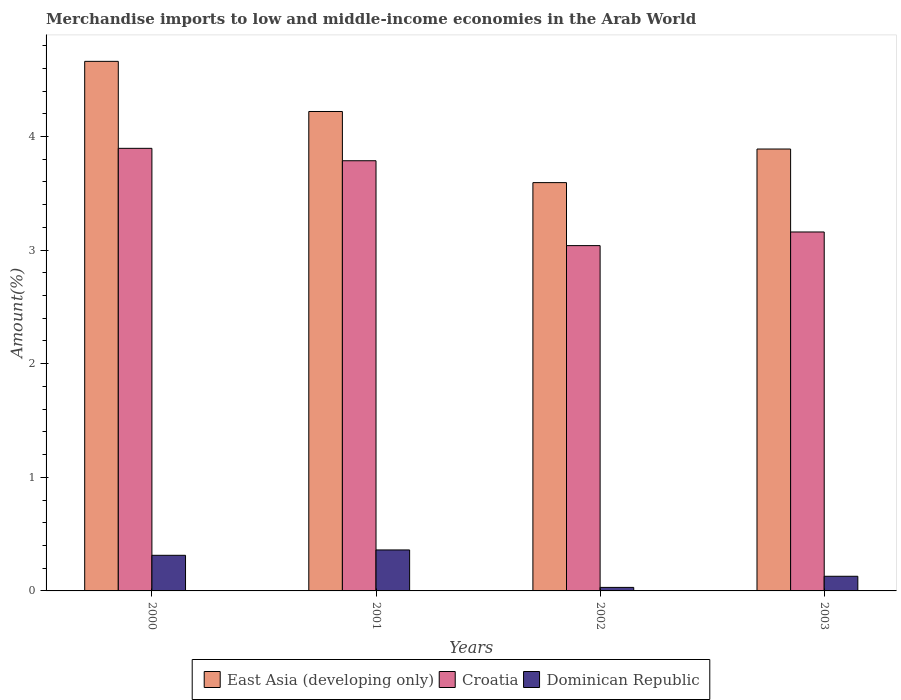How many bars are there on the 3rd tick from the left?
Your answer should be compact. 3. In how many cases, is the number of bars for a given year not equal to the number of legend labels?
Your response must be concise. 0. What is the percentage of amount earned from merchandise imports in Dominican Republic in 2002?
Offer a very short reply. 0.03. Across all years, what is the maximum percentage of amount earned from merchandise imports in Dominican Republic?
Keep it short and to the point. 0.36. Across all years, what is the minimum percentage of amount earned from merchandise imports in East Asia (developing only)?
Make the answer very short. 3.59. In which year was the percentage of amount earned from merchandise imports in Croatia minimum?
Keep it short and to the point. 2002. What is the total percentage of amount earned from merchandise imports in Dominican Republic in the graph?
Ensure brevity in your answer.  0.83. What is the difference between the percentage of amount earned from merchandise imports in Dominican Republic in 2001 and that in 2003?
Make the answer very short. 0.23. What is the difference between the percentage of amount earned from merchandise imports in East Asia (developing only) in 2000 and the percentage of amount earned from merchandise imports in Croatia in 2003?
Provide a short and direct response. 1.5. What is the average percentage of amount earned from merchandise imports in Dominican Republic per year?
Provide a short and direct response. 0.21. In the year 2002, what is the difference between the percentage of amount earned from merchandise imports in Croatia and percentage of amount earned from merchandise imports in Dominican Republic?
Keep it short and to the point. 3.01. What is the ratio of the percentage of amount earned from merchandise imports in Croatia in 2000 to that in 2001?
Your answer should be compact. 1.03. Is the difference between the percentage of amount earned from merchandise imports in Croatia in 2000 and 2002 greater than the difference between the percentage of amount earned from merchandise imports in Dominican Republic in 2000 and 2002?
Your response must be concise. Yes. What is the difference between the highest and the second highest percentage of amount earned from merchandise imports in East Asia (developing only)?
Your response must be concise. 0.44. What is the difference between the highest and the lowest percentage of amount earned from merchandise imports in Croatia?
Provide a succinct answer. 0.86. Is the sum of the percentage of amount earned from merchandise imports in East Asia (developing only) in 2002 and 2003 greater than the maximum percentage of amount earned from merchandise imports in Dominican Republic across all years?
Give a very brief answer. Yes. What does the 3rd bar from the left in 2002 represents?
Your answer should be compact. Dominican Republic. What does the 3rd bar from the right in 2001 represents?
Give a very brief answer. East Asia (developing only). Are all the bars in the graph horizontal?
Provide a short and direct response. No. How many years are there in the graph?
Your response must be concise. 4. Are the values on the major ticks of Y-axis written in scientific E-notation?
Give a very brief answer. No. Does the graph contain grids?
Offer a terse response. No. What is the title of the graph?
Ensure brevity in your answer.  Merchandise imports to low and middle-income economies in the Arab World. Does "Heavily indebted poor countries" appear as one of the legend labels in the graph?
Keep it short and to the point. No. What is the label or title of the Y-axis?
Your response must be concise. Amount(%). What is the Amount(%) in East Asia (developing only) in 2000?
Keep it short and to the point. 4.66. What is the Amount(%) in Croatia in 2000?
Keep it short and to the point. 3.9. What is the Amount(%) of Dominican Republic in 2000?
Your response must be concise. 0.31. What is the Amount(%) in East Asia (developing only) in 2001?
Provide a succinct answer. 4.22. What is the Amount(%) in Croatia in 2001?
Offer a terse response. 3.79. What is the Amount(%) of Dominican Republic in 2001?
Your answer should be compact. 0.36. What is the Amount(%) in East Asia (developing only) in 2002?
Your answer should be very brief. 3.59. What is the Amount(%) in Croatia in 2002?
Your answer should be very brief. 3.04. What is the Amount(%) of Dominican Republic in 2002?
Make the answer very short. 0.03. What is the Amount(%) of East Asia (developing only) in 2003?
Your answer should be very brief. 3.89. What is the Amount(%) in Croatia in 2003?
Keep it short and to the point. 3.16. What is the Amount(%) of Dominican Republic in 2003?
Your response must be concise. 0.13. Across all years, what is the maximum Amount(%) of East Asia (developing only)?
Make the answer very short. 4.66. Across all years, what is the maximum Amount(%) of Croatia?
Your response must be concise. 3.9. Across all years, what is the maximum Amount(%) in Dominican Republic?
Your response must be concise. 0.36. Across all years, what is the minimum Amount(%) in East Asia (developing only)?
Offer a terse response. 3.59. Across all years, what is the minimum Amount(%) in Croatia?
Your answer should be compact. 3.04. Across all years, what is the minimum Amount(%) in Dominican Republic?
Provide a succinct answer. 0.03. What is the total Amount(%) in East Asia (developing only) in the graph?
Provide a succinct answer. 16.36. What is the total Amount(%) of Croatia in the graph?
Provide a succinct answer. 13.88. What is the total Amount(%) in Dominican Republic in the graph?
Give a very brief answer. 0.83. What is the difference between the Amount(%) of East Asia (developing only) in 2000 and that in 2001?
Provide a succinct answer. 0.44. What is the difference between the Amount(%) in Croatia in 2000 and that in 2001?
Your answer should be very brief. 0.11. What is the difference between the Amount(%) in Dominican Republic in 2000 and that in 2001?
Offer a very short reply. -0.05. What is the difference between the Amount(%) of East Asia (developing only) in 2000 and that in 2002?
Provide a succinct answer. 1.07. What is the difference between the Amount(%) of Croatia in 2000 and that in 2002?
Keep it short and to the point. 0.86. What is the difference between the Amount(%) of Dominican Republic in 2000 and that in 2002?
Offer a terse response. 0.28. What is the difference between the Amount(%) of East Asia (developing only) in 2000 and that in 2003?
Offer a very short reply. 0.77. What is the difference between the Amount(%) in Croatia in 2000 and that in 2003?
Your answer should be very brief. 0.74. What is the difference between the Amount(%) of Dominican Republic in 2000 and that in 2003?
Your response must be concise. 0.18. What is the difference between the Amount(%) in East Asia (developing only) in 2001 and that in 2002?
Ensure brevity in your answer.  0.63. What is the difference between the Amount(%) of Croatia in 2001 and that in 2002?
Offer a terse response. 0.75. What is the difference between the Amount(%) of Dominican Republic in 2001 and that in 2002?
Your response must be concise. 0.33. What is the difference between the Amount(%) in East Asia (developing only) in 2001 and that in 2003?
Provide a succinct answer. 0.33. What is the difference between the Amount(%) of Croatia in 2001 and that in 2003?
Give a very brief answer. 0.63. What is the difference between the Amount(%) of Dominican Republic in 2001 and that in 2003?
Offer a terse response. 0.23. What is the difference between the Amount(%) of East Asia (developing only) in 2002 and that in 2003?
Give a very brief answer. -0.3. What is the difference between the Amount(%) of Croatia in 2002 and that in 2003?
Provide a succinct answer. -0.12. What is the difference between the Amount(%) of Dominican Republic in 2002 and that in 2003?
Make the answer very short. -0.1. What is the difference between the Amount(%) of East Asia (developing only) in 2000 and the Amount(%) of Croatia in 2001?
Keep it short and to the point. 0.87. What is the difference between the Amount(%) of East Asia (developing only) in 2000 and the Amount(%) of Dominican Republic in 2001?
Offer a terse response. 4.3. What is the difference between the Amount(%) of Croatia in 2000 and the Amount(%) of Dominican Republic in 2001?
Ensure brevity in your answer.  3.53. What is the difference between the Amount(%) of East Asia (developing only) in 2000 and the Amount(%) of Croatia in 2002?
Give a very brief answer. 1.62. What is the difference between the Amount(%) in East Asia (developing only) in 2000 and the Amount(%) in Dominican Republic in 2002?
Your response must be concise. 4.63. What is the difference between the Amount(%) in Croatia in 2000 and the Amount(%) in Dominican Republic in 2002?
Offer a very short reply. 3.86. What is the difference between the Amount(%) in East Asia (developing only) in 2000 and the Amount(%) in Croatia in 2003?
Provide a short and direct response. 1.5. What is the difference between the Amount(%) of East Asia (developing only) in 2000 and the Amount(%) of Dominican Republic in 2003?
Offer a very short reply. 4.53. What is the difference between the Amount(%) in Croatia in 2000 and the Amount(%) in Dominican Republic in 2003?
Provide a short and direct response. 3.77. What is the difference between the Amount(%) in East Asia (developing only) in 2001 and the Amount(%) in Croatia in 2002?
Offer a very short reply. 1.18. What is the difference between the Amount(%) in East Asia (developing only) in 2001 and the Amount(%) in Dominican Republic in 2002?
Provide a short and direct response. 4.19. What is the difference between the Amount(%) of Croatia in 2001 and the Amount(%) of Dominican Republic in 2002?
Your answer should be very brief. 3.76. What is the difference between the Amount(%) in East Asia (developing only) in 2001 and the Amount(%) in Croatia in 2003?
Keep it short and to the point. 1.06. What is the difference between the Amount(%) of East Asia (developing only) in 2001 and the Amount(%) of Dominican Republic in 2003?
Offer a terse response. 4.09. What is the difference between the Amount(%) in Croatia in 2001 and the Amount(%) in Dominican Republic in 2003?
Give a very brief answer. 3.66. What is the difference between the Amount(%) of East Asia (developing only) in 2002 and the Amount(%) of Croatia in 2003?
Make the answer very short. 0.43. What is the difference between the Amount(%) in East Asia (developing only) in 2002 and the Amount(%) in Dominican Republic in 2003?
Your response must be concise. 3.46. What is the difference between the Amount(%) in Croatia in 2002 and the Amount(%) in Dominican Republic in 2003?
Provide a short and direct response. 2.91. What is the average Amount(%) in East Asia (developing only) per year?
Keep it short and to the point. 4.09. What is the average Amount(%) of Croatia per year?
Your answer should be very brief. 3.47. What is the average Amount(%) in Dominican Republic per year?
Provide a succinct answer. 0.21. In the year 2000, what is the difference between the Amount(%) in East Asia (developing only) and Amount(%) in Croatia?
Offer a very short reply. 0.77. In the year 2000, what is the difference between the Amount(%) in East Asia (developing only) and Amount(%) in Dominican Republic?
Keep it short and to the point. 4.35. In the year 2000, what is the difference between the Amount(%) in Croatia and Amount(%) in Dominican Republic?
Give a very brief answer. 3.58. In the year 2001, what is the difference between the Amount(%) in East Asia (developing only) and Amount(%) in Croatia?
Provide a succinct answer. 0.43. In the year 2001, what is the difference between the Amount(%) of East Asia (developing only) and Amount(%) of Dominican Republic?
Offer a terse response. 3.86. In the year 2001, what is the difference between the Amount(%) of Croatia and Amount(%) of Dominican Republic?
Offer a terse response. 3.43. In the year 2002, what is the difference between the Amount(%) in East Asia (developing only) and Amount(%) in Croatia?
Make the answer very short. 0.55. In the year 2002, what is the difference between the Amount(%) in East Asia (developing only) and Amount(%) in Dominican Republic?
Your response must be concise. 3.56. In the year 2002, what is the difference between the Amount(%) in Croatia and Amount(%) in Dominican Republic?
Provide a succinct answer. 3.01. In the year 2003, what is the difference between the Amount(%) of East Asia (developing only) and Amount(%) of Croatia?
Make the answer very short. 0.73. In the year 2003, what is the difference between the Amount(%) in East Asia (developing only) and Amount(%) in Dominican Republic?
Ensure brevity in your answer.  3.76. In the year 2003, what is the difference between the Amount(%) of Croatia and Amount(%) of Dominican Republic?
Give a very brief answer. 3.03. What is the ratio of the Amount(%) in East Asia (developing only) in 2000 to that in 2001?
Your answer should be very brief. 1.1. What is the ratio of the Amount(%) in Croatia in 2000 to that in 2001?
Keep it short and to the point. 1.03. What is the ratio of the Amount(%) in Dominican Republic in 2000 to that in 2001?
Give a very brief answer. 0.87. What is the ratio of the Amount(%) of East Asia (developing only) in 2000 to that in 2002?
Provide a short and direct response. 1.3. What is the ratio of the Amount(%) of Croatia in 2000 to that in 2002?
Give a very brief answer. 1.28. What is the ratio of the Amount(%) in Dominican Republic in 2000 to that in 2002?
Provide a short and direct response. 10.09. What is the ratio of the Amount(%) of East Asia (developing only) in 2000 to that in 2003?
Provide a succinct answer. 1.2. What is the ratio of the Amount(%) of Croatia in 2000 to that in 2003?
Your answer should be compact. 1.23. What is the ratio of the Amount(%) in Dominican Republic in 2000 to that in 2003?
Keep it short and to the point. 2.43. What is the ratio of the Amount(%) of East Asia (developing only) in 2001 to that in 2002?
Provide a short and direct response. 1.17. What is the ratio of the Amount(%) of Croatia in 2001 to that in 2002?
Give a very brief answer. 1.25. What is the ratio of the Amount(%) in Dominican Republic in 2001 to that in 2002?
Make the answer very short. 11.61. What is the ratio of the Amount(%) of East Asia (developing only) in 2001 to that in 2003?
Make the answer very short. 1.08. What is the ratio of the Amount(%) of Croatia in 2001 to that in 2003?
Your answer should be very brief. 1.2. What is the ratio of the Amount(%) of Dominican Republic in 2001 to that in 2003?
Provide a succinct answer. 2.8. What is the ratio of the Amount(%) of East Asia (developing only) in 2002 to that in 2003?
Make the answer very short. 0.92. What is the ratio of the Amount(%) in Dominican Republic in 2002 to that in 2003?
Your answer should be compact. 0.24. What is the difference between the highest and the second highest Amount(%) in East Asia (developing only)?
Offer a terse response. 0.44. What is the difference between the highest and the second highest Amount(%) of Croatia?
Your response must be concise. 0.11. What is the difference between the highest and the second highest Amount(%) in Dominican Republic?
Keep it short and to the point. 0.05. What is the difference between the highest and the lowest Amount(%) in East Asia (developing only)?
Your answer should be very brief. 1.07. What is the difference between the highest and the lowest Amount(%) in Croatia?
Make the answer very short. 0.86. What is the difference between the highest and the lowest Amount(%) in Dominican Republic?
Keep it short and to the point. 0.33. 